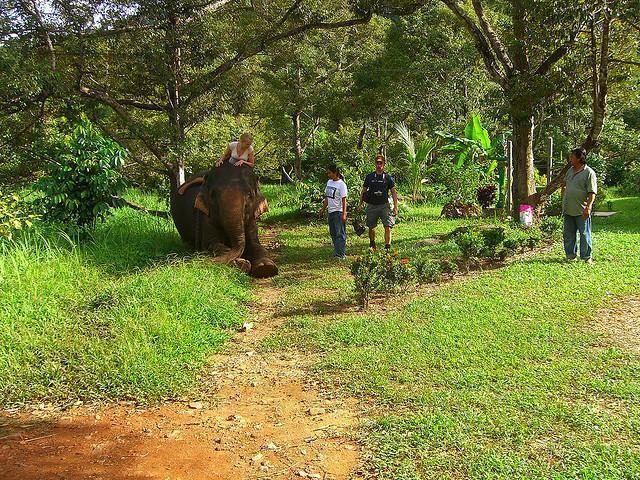How many people are in the photo?
Give a very brief answer. 4. How many people can you see?
Give a very brief answer. 2. 